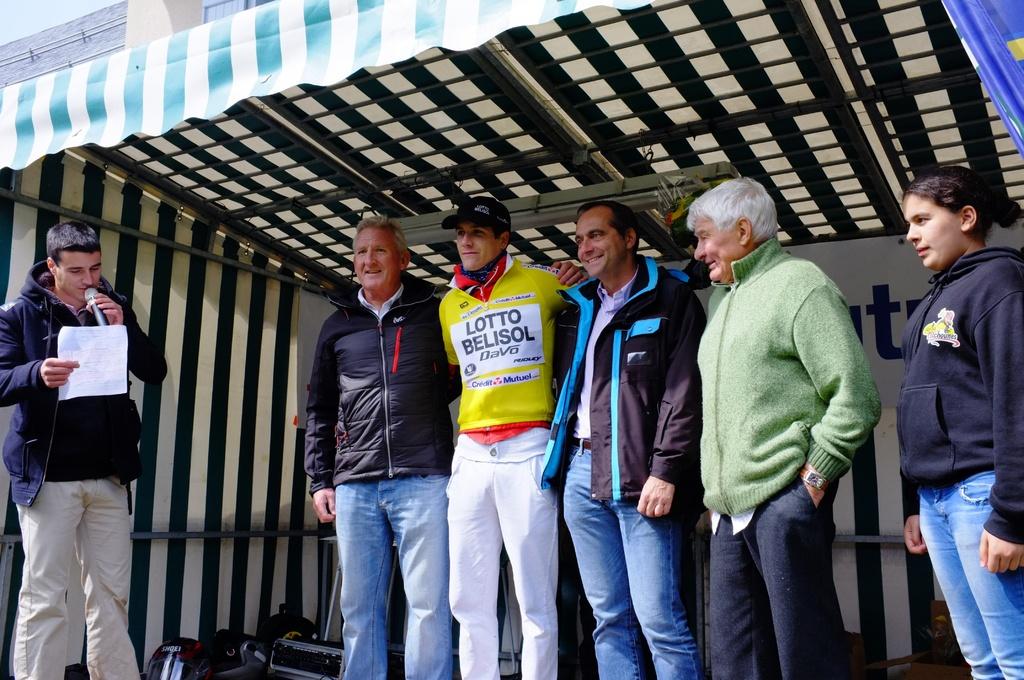What kind of lotto is the sponsor?
Ensure brevity in your answer.  Belisol. Whats the lotto about?
Offer a terse response. Belisol. 